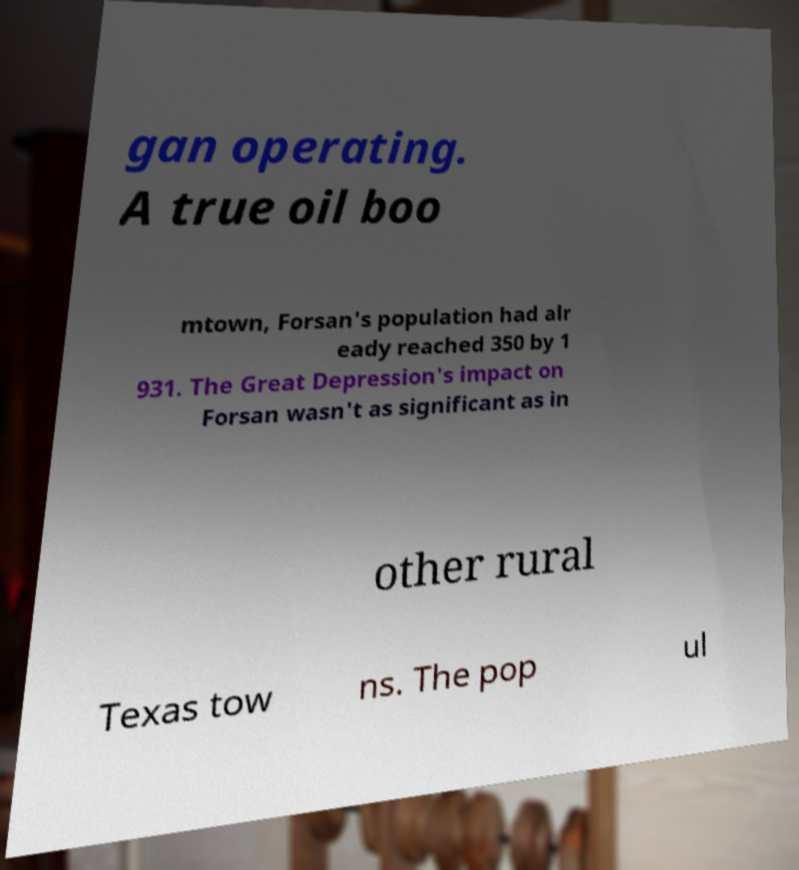Could you extract and type out the text from this image? gan operating. A true oil boo mtown, Forsan's population had alr eady reached 350 by 1 931. The Great Depression's impact on Forsan wasn't as significant as in other rural Texas tow ns. The pop ul 